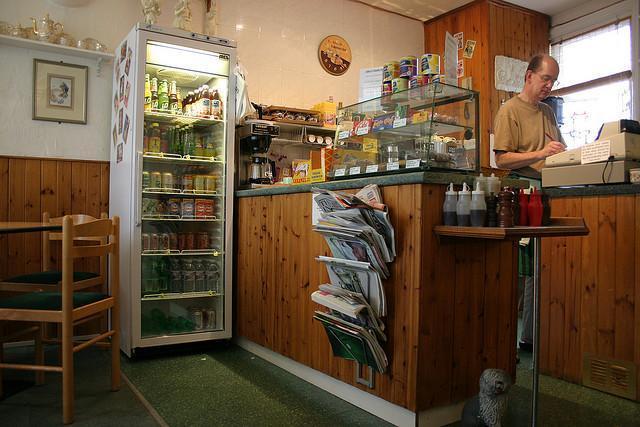How many price tags are on the top shelf?
Give a very brief answer. 3. How many chairs are there?
Give a very brief answer. 2. 